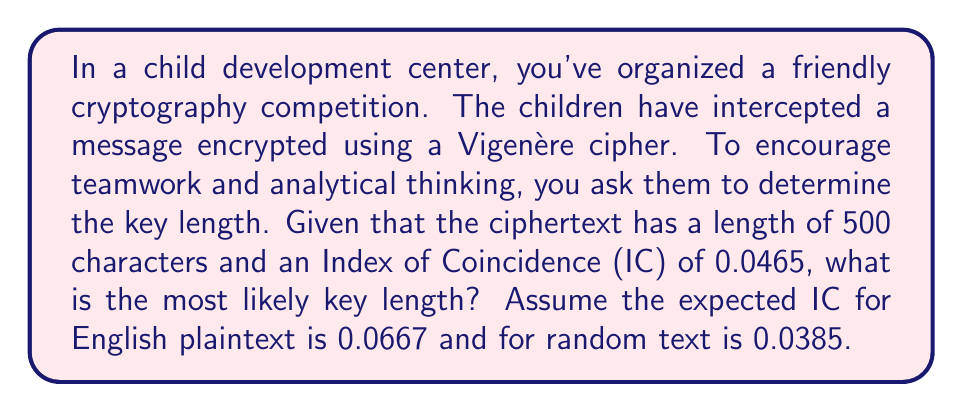Help me with this question. Let's approach this step-by-step:

1) The formula for the Index of Coincidence (IC) in relation to key length is:

   $$IC = \frac{1}{L} \cdot IC_{p} + \frac{L-1}{L} \cdot IC_{r}$$

   Where:
   $L$ is the key length
   $IC_{p}$ is the IC of the plaintext language (0.0667 for English)
   $IC_{r}$ is the IC of random text (0.0385)

2) We can rearrange this formula to solve for $L$:

   $$0.0465 = \frac{1}{L} \cdot 0.0667 + \frac{L-1}{L} \cdot 0.0385$$

3) Multiply both sides by $L$:

   $$0.0465L = 0.0667 + 0.0385L - 0.0385$$

4) Simplify:

   $$0.0465L = 0.0282 + 0.0385L$$

5) Subtract $0.0385L$ from both sides:

   $$0.008L = 0.0282$$

6) Divide both sides by 0.008:

   $$L = \frac{0.0282}{0.008} = 3.525$$

7) Since the key length must be an integer, we round to the nearest whole number.
Answer: 4 